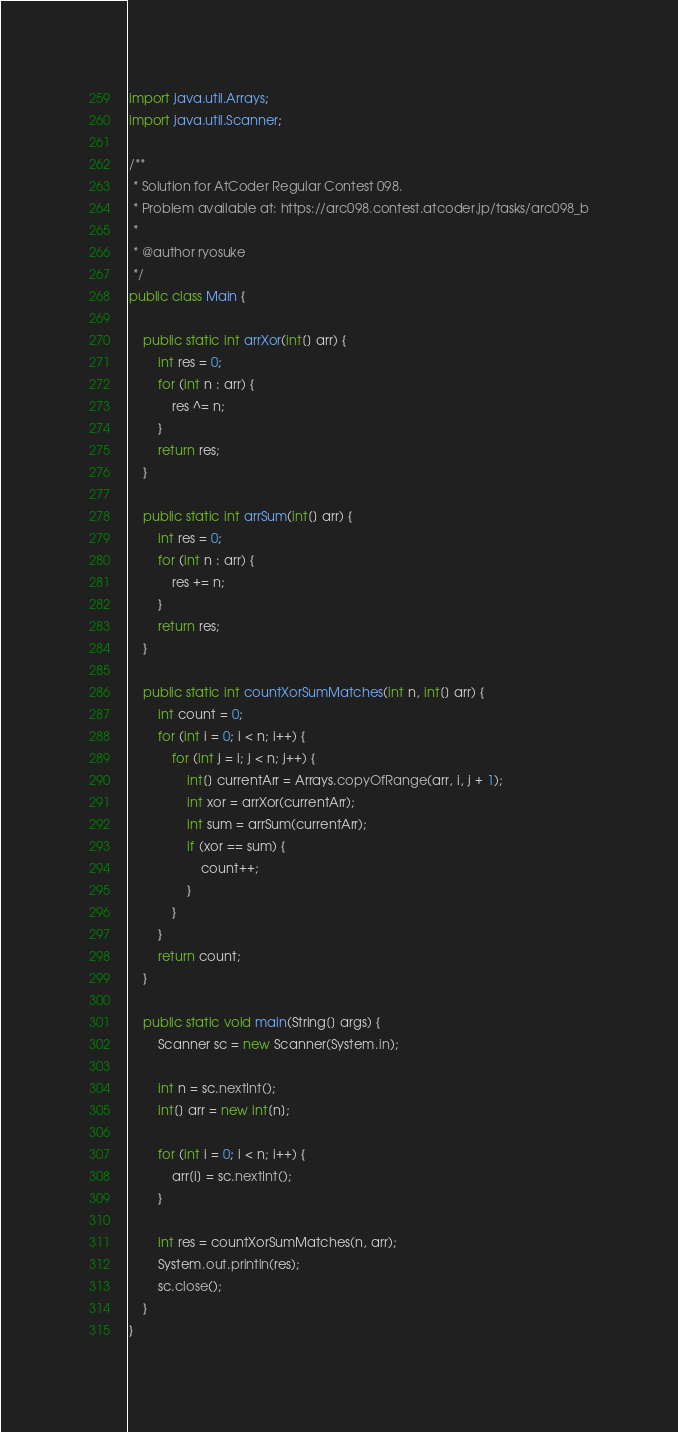Convert code to text. <code><loc_0><loc_0><loc_500><loc_500><_Java_>import java.util.Arrays;
import java.util.Scanner;

/**
 * Solution for AtCoder Regular Contest 098.
 * Problem available at: https://arc098.contest.atcoder.jp/tasks/arc098_b
 *
 * @author ryosuke
 */
public class Main {

    public static int arrXor(int[] arr) {
        int res = 0;
        for (int n : arr) {
            res ^= n;
        }
        return res;
    }

    public static int arrSum(int[] arr) {
        int res = 0;
        for (int n : arr) {
            res += n;
        }
        return res;
    }

    public static int countXorSumMatches(int n, int[] arr) {
        int count = 0;
        for (int i = 0; i < n; i++) {
            for (int j = i; j < n; j++) {
                int[] currentArr = Arrays.copyOfRange(arr, i, j + 1);
                int xor = arrXor(currentArr);
                int sum = arrSum(currentArr);
                if (xor == sum) {
                    count++;
                }
            }
        }
        return count;
    }

    public static void main(String[] args) {
        Scanner sc = new Scanner(System.in);

        int n = sc.nextInt();
        int[] arr = new int[n];

        for (int i = 0; i < n; i++) {
            arr[i] = sc.nextInt();
        }

        int res = countXorSumMatches(n, arr);
        System.out.println(res);
        sc.close();
    }
}
</code> 